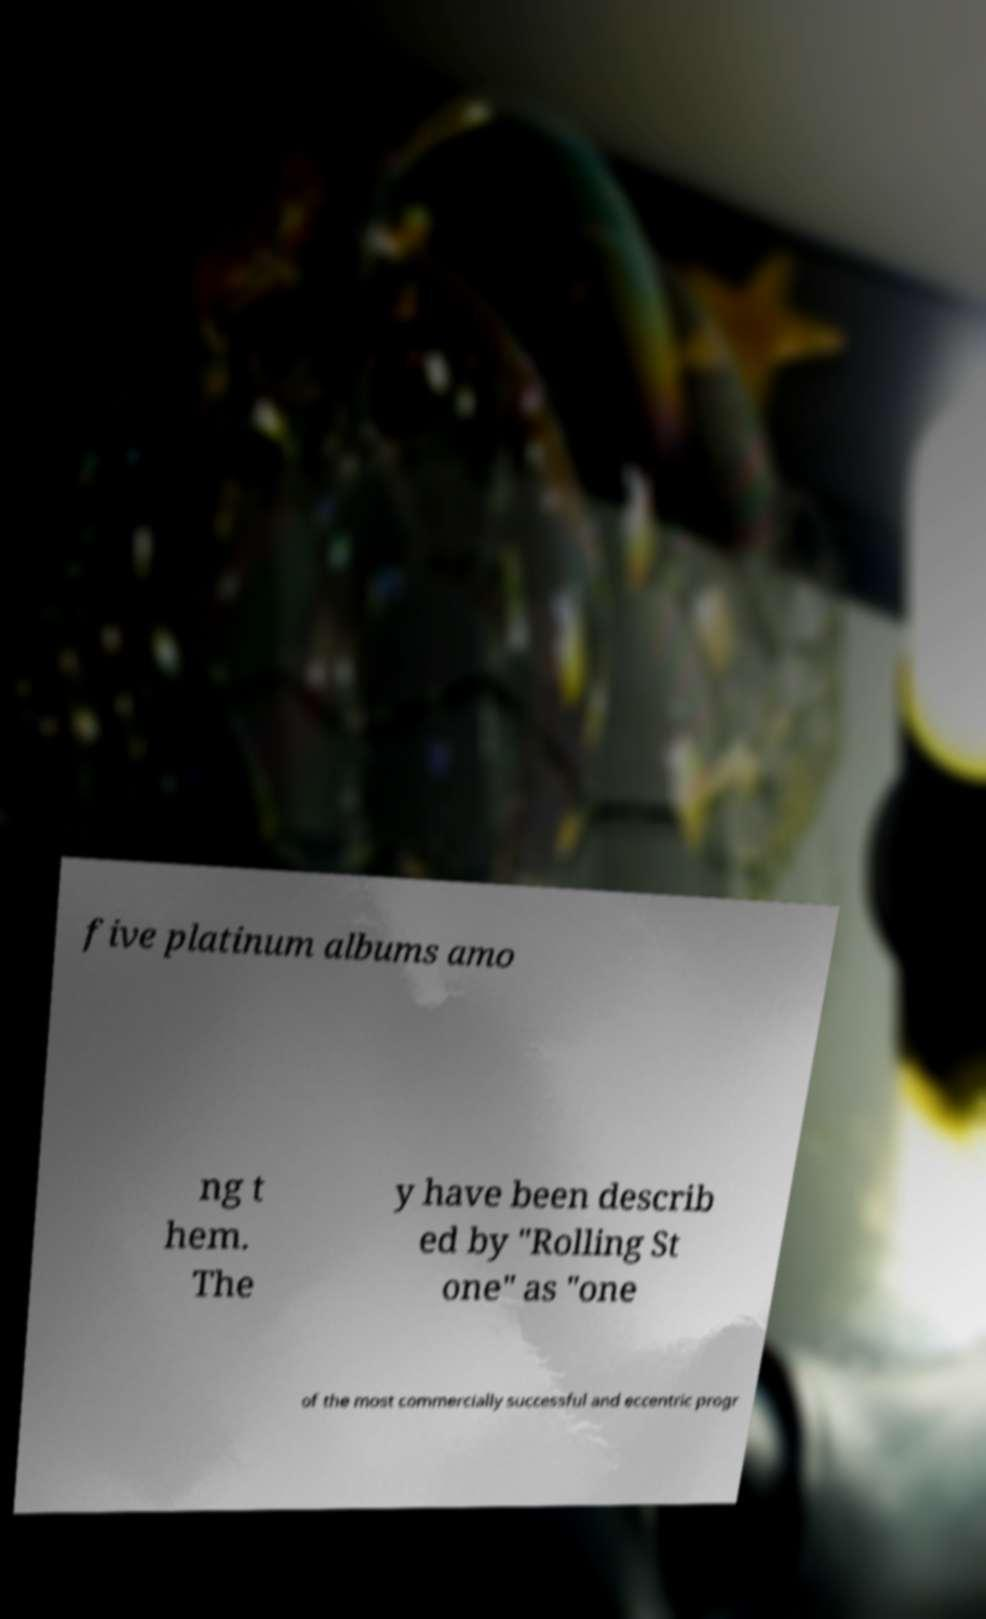What messages or text are displayed in this image? I need them in a readable, typed format. five platinum albums amo ng t hem. The y have been describ ed by "Rolling St one" as "one of the most commercially successful and eccentric progr 